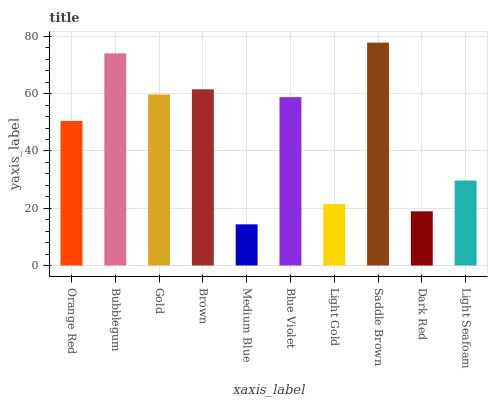Is Bubblegum the minimum?
Answer yes or no. No. Is Bubblegum the maximum?
Answer yes or no. No. Is Bubblegum greater than Orange Red?
Answer yes or no. Yes. Is Orange Red less than Bubblegum?
Answer yes or no. Yes. Is Orange Red greater than Bubblegum?
Answer yes or no. No. Is Bubblegum less than Orange Red?
Answer yes or no. No. Is Blue Violet the high median?
Answer yes or no. Yes. Is Orange Red the low median?
Answer yes or no. Yes. Is Gold the high median?
Answer yes or no. No. Is Blue Violet the low median?
Answer yes or no. No. 